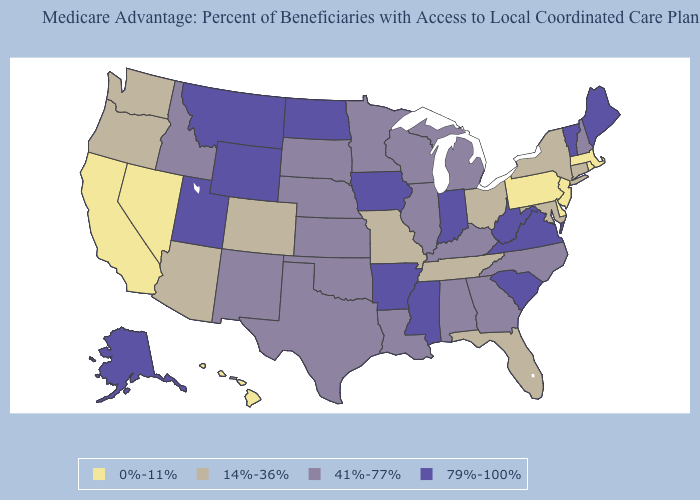Name the states that have a value in the range 41%-77%?
Keep it brief. Alabama, Georgia, Idaho, Illinois, Kansas, Kentucky, Louisiana, Michigan, Minnesota, North Carolina, Nebraska, New Hampshire, New Mexico, Oklahoma, South Dakota, Texas, Wisconsin. Among the states that border Texas , does Arkansas have the highest value?
Short answer required. Yes. What is the value of Arizona?
Give a very brief answer. 14%-36%. Among the states that border Iowa , which have the lowest value?
Give a very brief answer. Missouri. Name the states that have a value in the range 41%-77%?
Give a very brief answer. Alabama, Georgia, Idaho, Illinois, Kansas, Kentucky, Louisiana, Michigan, Minnesota, North Carolina, Nebraska, New Hampshire, New Mexico, Oklahoma, South Dakota, Texas, Wisconsin. What is the lowest value in the USA?
Keep it brief. 0%-11%. Which states have the highest value in the USA?
Answer briefly. Alaska, Arkansas, Iowa, Indiana, Maine, Mississippi, Montana, North Dakota, South Carolina, Utah, Virginia, Vermont, West Virginia, Wyoming. Does the map have missing data?
Short answer required. No. Among the states that border Oklahoma , does Colorado have the lowest value?
Be succinct. Yes. Does Mississippi have the same value as Washington?
Quick response, please. No. Among the states that border Mississippi , which have the highest value?
Be succinct. Arkansas. Name the states that have a value in the range 41%-77%?
Short answer required. Alabama, Georgia, Idaho, Illinois, Kansas, Kentucky, Louisiana, Michigan, Minnesota, North Carolina, Nebraska, New Hampshire, New Mexico, Oklahoma, South Dakota, Texas, Wisconsin. Is the legend a continuous bar?
Short answer required. No. Which states have the lowest value in the Northeast?
Concise answer only. Massachusetts, New Jersey, Pennsylvania, Rhode Island. Does North Dakota have the highest value in the MidWest?
Keep it brief. Yes. 